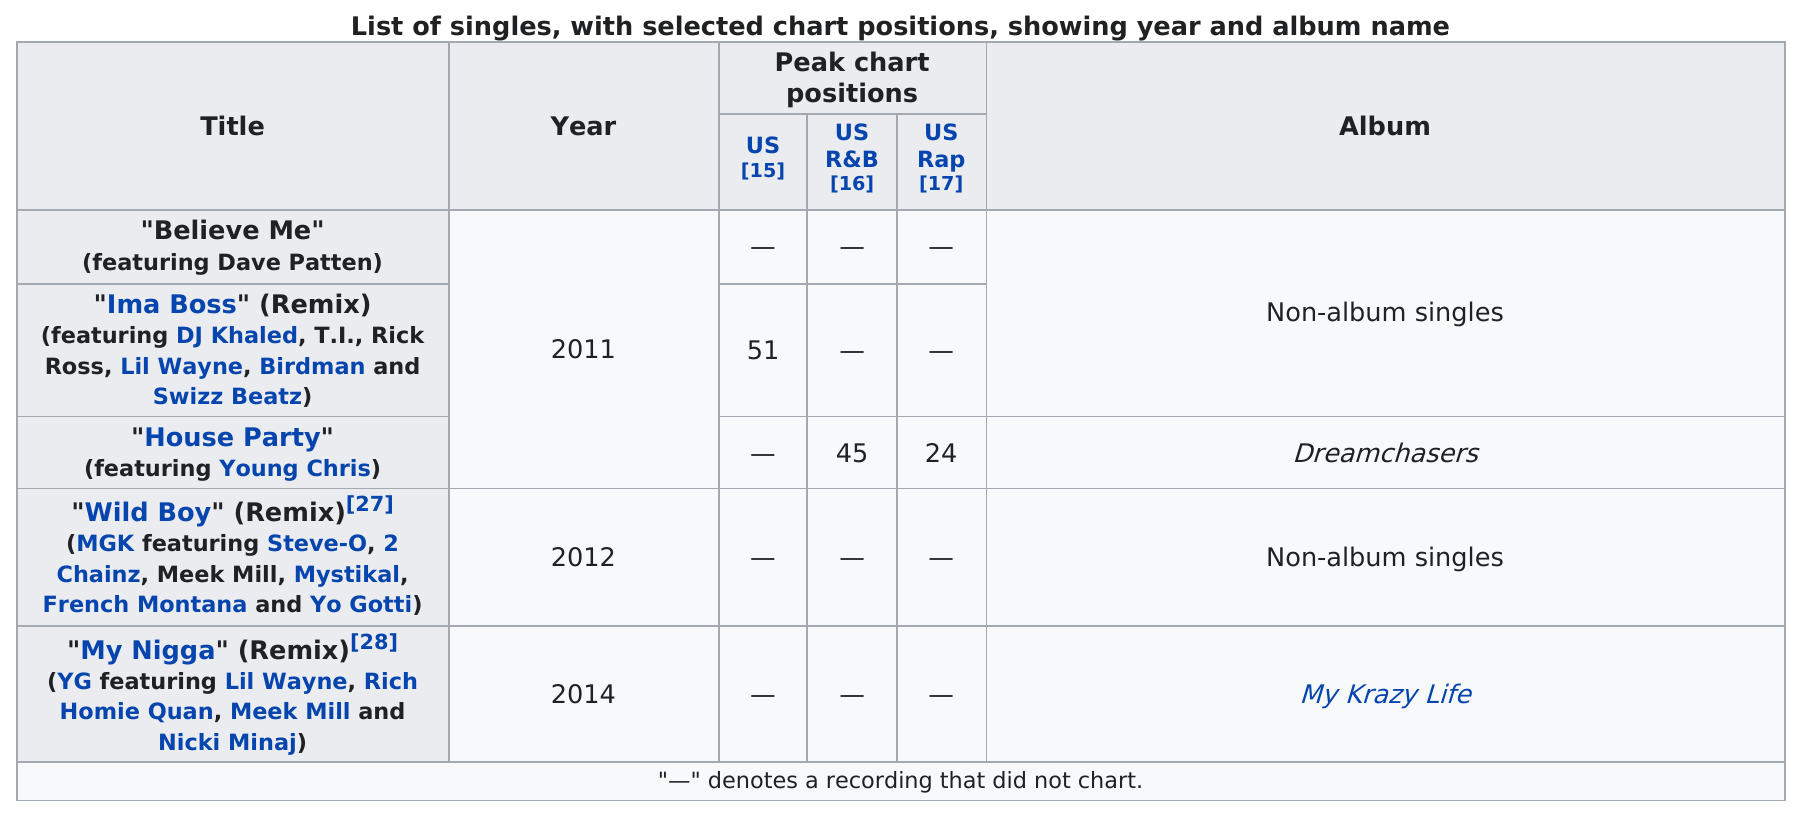Outline some significant characteristics in this image. The next single after "House Party" was "Wild Boy" (Remix), which featured Steve-O, 2 Chainz, Meek Mill, Mystikal, French Montana, and Yo Gotti. Dave Patten is featured in a song called "believe me. The song 'House Party,' featuring Young Chris, had a peak chart position of 45 and 24. There are three non-album singles. There are five singles featured in the table. 